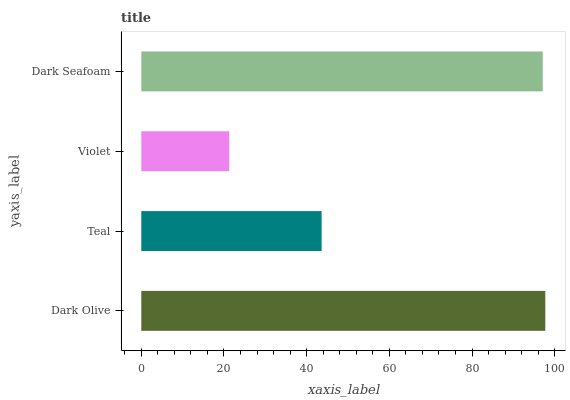Is Violet the minimum?
Answer yes or no. Yes. Is Dark Olive the maximum?
Answer yes or no. Yes. Is Teal the minimum?
Answer yes or no. No. Is Teal the maximum?
Answer yes or no. No. Is Dark Olive greater than Teal?
Answer yes or no. Yes. Is Teal less than Dark Olive?
Answer yes or no. Yes. Is Teal greater than Dark Olive?
Answer yes or no. No. Is Dark Olive less than Teal?
Answer yes or no. No. Is Dark Seafoam the high median?
Answer yes or no. Yes. Is Teal the low median?
Answer yes or no. Yes. Is Dark Olive the high median?
Answer yes or no. No. Is Violet the low median?
Answer yes or no. No. 